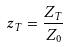<formula> <loc_0><loc_0><loc_500><loc_500>z _ { T } = \frac { Z _ { T } } { Z _ { 0 } }</formula> 